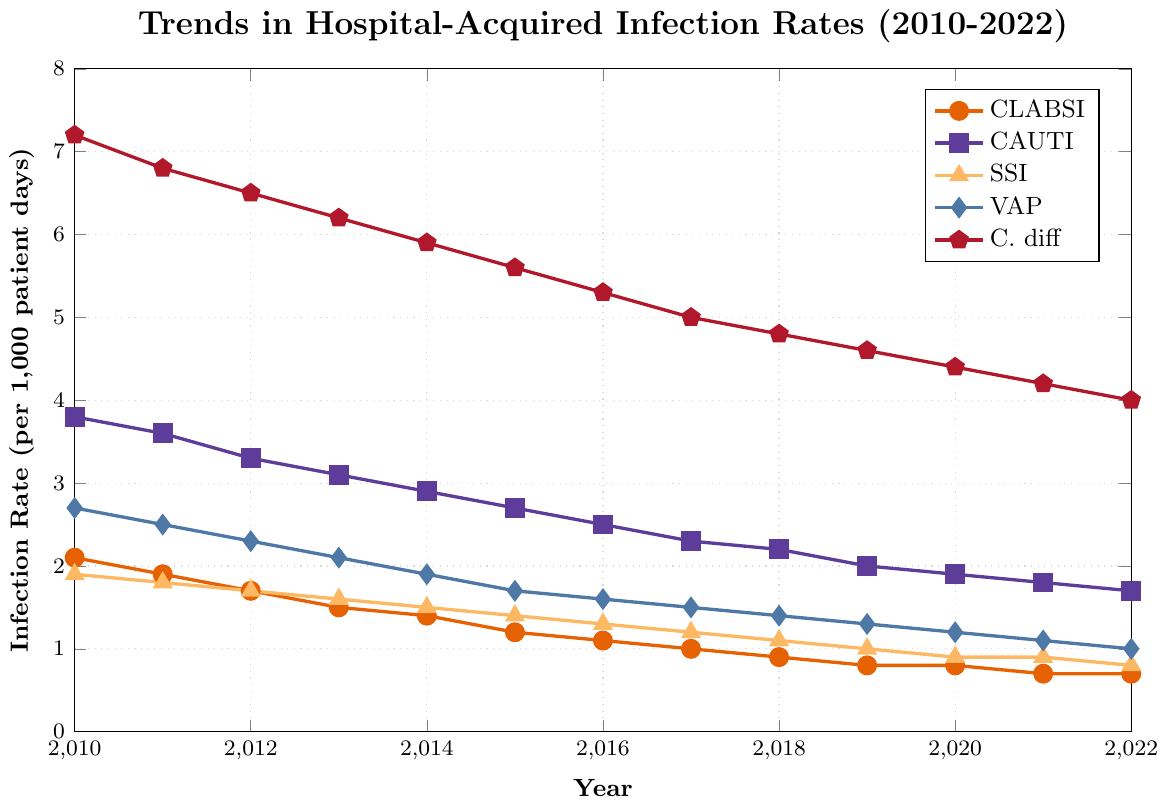What is the infection rate of CAUTI in 2013? In the figure, find the point along the line labeled “CAUTI” for the year 2013. The y-axis value at this point represents the infection rate.
Answer: 3.1 Between which years did VAP see the most significant decrease in infection rate? Observe the slope of the line labeled “VAP” and identify the steepest decline between any two consecutive years.
Answer: 2012 to 2013 Which infection type had the highest rate in 2010? Compare the y-axis values for each infection type line at the year 2010. The highest value indicates the infection type with the highest rate.
Answer: C. diff On average, how much did the CLABSI infection rate decrease each year from 2010 to 2022? Calculate the total decrease in infection rate (initial rate in 2010 minus final rate in 2022) and divide by the number of years (2022 - 2010).
Answer: (2.1 - 0.7) / 12 = 0.1167 Which infection type has the most consistent decreasing trend over the years? Analyze the lines and determine which infection type line appears to consistently decrease with minimal fluctuation.
Answer: VAP By how much did the SSI infection rate decrease from 2010 to 2022? Subtract the SSI infection rate in 2022 from the rate in 2010.
Answer: 1.9 - 0.8 = 1.1 Which infections had a rate lower than 2.0 by 2022? Check the final y-axis value (2022) for each infection type, and identify those below 2.0.
Answer: CLABSI, CAUTI, SSI, VAP What color represents the infection type with the highest rate in 2021? Find the highest infection rate in 2021, then identify the color of the line representing that infection type.
Answer: Red (C. diff) Which infection type's rate remained unchanged from 2020 to 2021? Examine the change in rate for each infection type between 2020 and 2021 to see which line shows no change.
Answer: SSI From 2010 to 2022, which infection type saw the greatest total decrease in its infection rate? Calculate the total decrease for each infection type and determine which one had the largest decrease.
Answer: C. diff (7.2 - 4.0 = 3.2) 